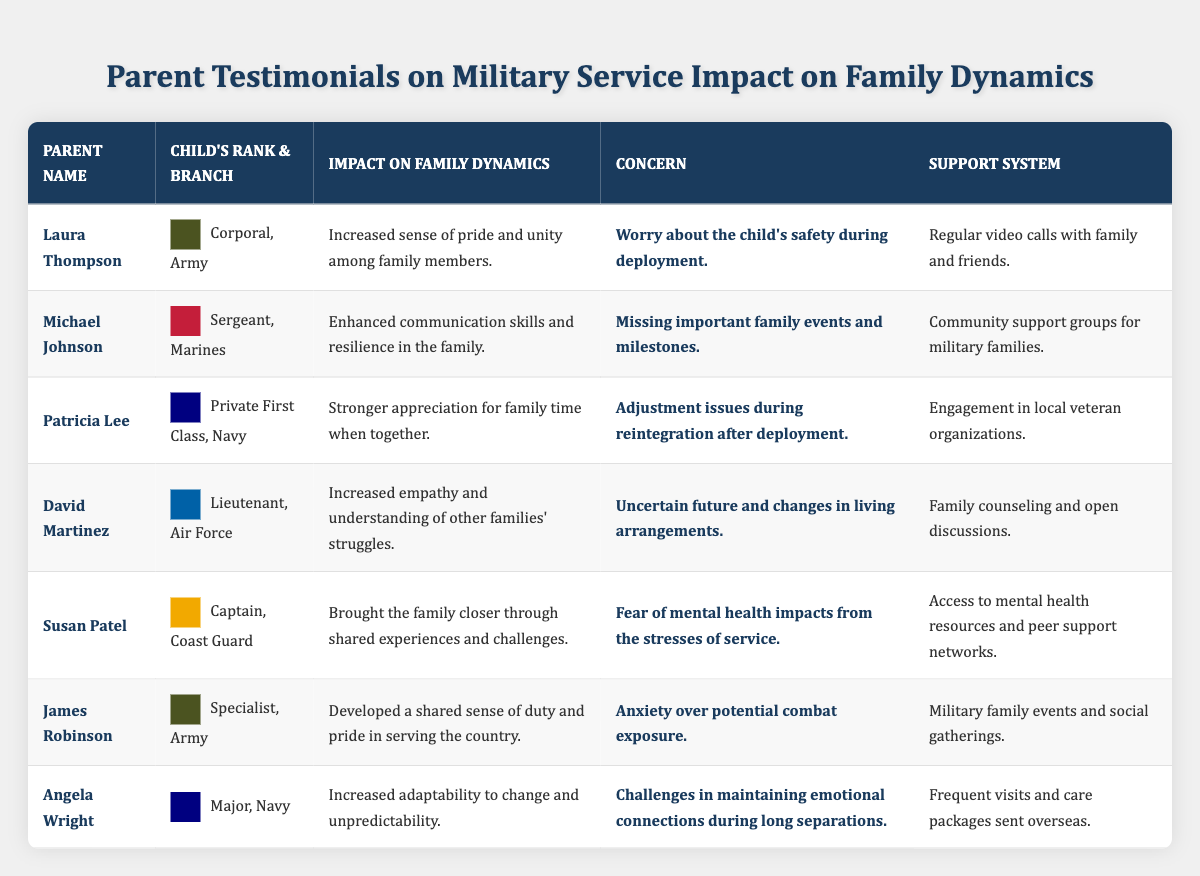What is the impact on family dynamics mentioned by Laura Thompson? Laura Thompson's statement highlights that the impact on family dynamics is "Increased sense of pride and unity among family members." This information is located in the corresponding row under the "Impact on Family Dynamics" column for her.
Answer: Increased sense of pride and unity among family members Which parent expressed concern about missing important family events? The concern expressed about missing important family events is associated with Michael Johnson. It can be found in his row under the "Concern" column where it states, "Missing important family events and milestones."
Answer: Michael Johnson How many parents mention challenges related to mental health impacts from military service? There are two parents—Susan Patel and Angela Wright—who mention concerns regarding mental health impacts. This can be confirmed by looking at their respective "Concern" entries in the table.
Answer: Two parents What is the primary concern of David Martinez regarding his child's service? The primary concern for David Martinez, as noted in the table, is "Uncertain future and changes in living arrangements," which can be found in the "Concern" column of his row.
Answer: Uncertain future and changes in living arrangements Which branch of service does Patricia Lee's child belong to? Patricia Lee's child is in the Navy, as indicated by her entry in the "Child's Rank & Branch" column where it states "Private First Class, Navy."
Answer: Navy What commonalities can be found in the support systems identified by parents in this table? Several parents mention community or peer support as part of their support systems, such as Michael Johnson referring to "Community support groups for military families" and Susan Patel stating "Access to mental health resources and peer support networks." Thus, it indicates a shared reliance on community support.
Answer: Community or peer support is common Does any parent report anxiety due to potential combat exposure? Yes, James Robinson reports "Anxiety over potential combat exposure" in the "Concern" column. This can be confirmed by checking his row in the table.
Answer: Yes What is the overall sentiment expressed by parents regarding military service based on their testimonials? Overall, parents reflect a mix of pride in their children's service alongside concerns about safety and emotional well-being. For instance, many emphasize a "sense of pride" while also mentioning worries about deployment and mental health impacts, showing their dual feelings about the military service experience.
Answer: Mixed sentiment of pride and concern 